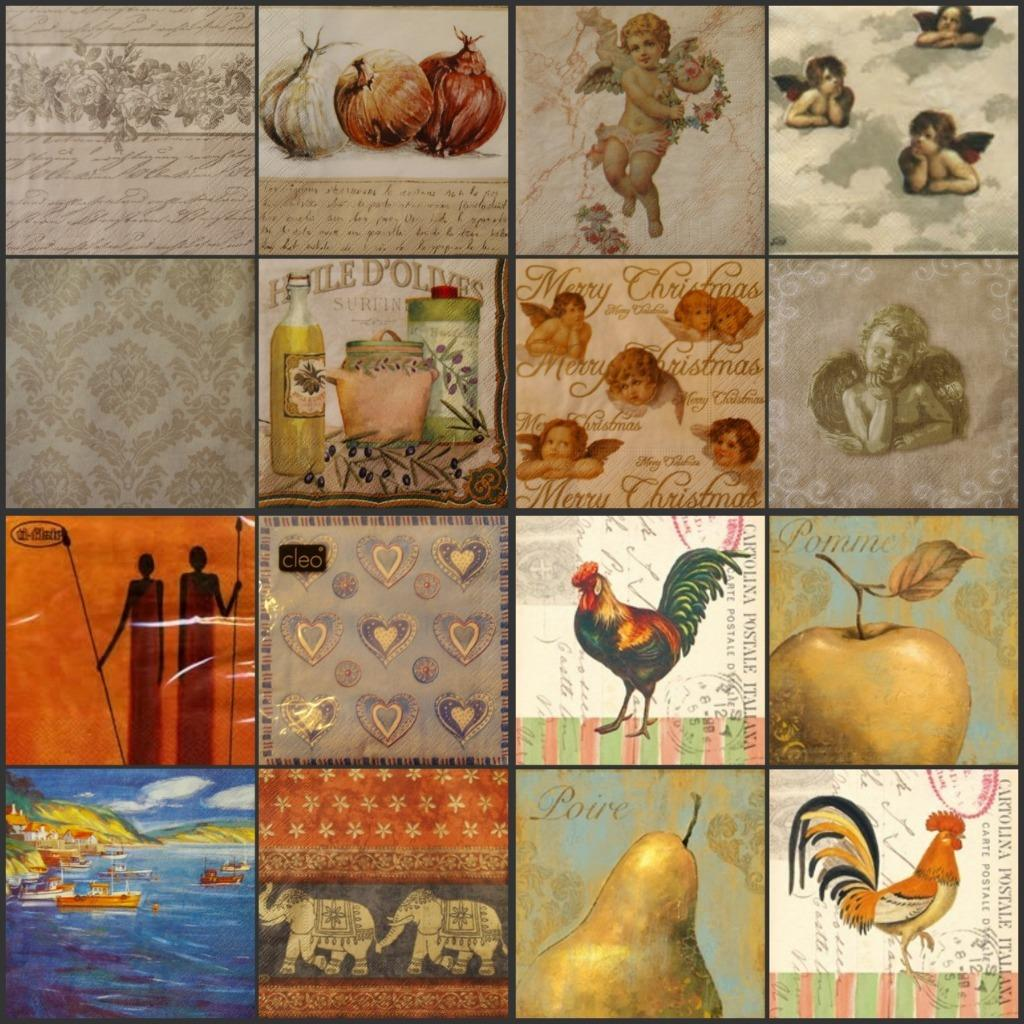What is the format of the image? The image is a collage of 8 pictures. What type of subjects are depicted in the collage? There are angels, a hen, a pear, and an apple depicted in the collage. Can you describe the subjects in more detail? The angels are depicted in the collage, as well as a hen, a pear, and an apple. What is the opinion of the worm in the image? There is no worm present in the image, so it is not possible to determine its opinion. 